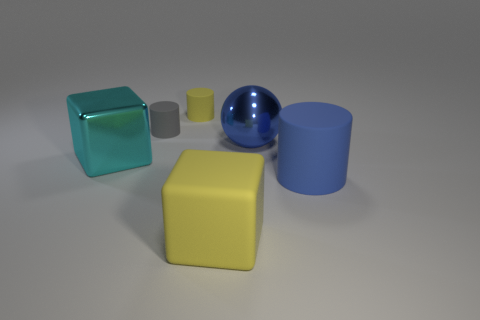There is a cylinder that is the same size as the ball; what color is it?
Give a very brief answer. Blue. What shape is the yellow rubber thing on the left side of the yellow thing in front of the large block that is on the left side of the small yellow matte cylinder?
Provide a succinct answer. Cylinder. There is a cylinder that is in front of the large cyan metallic block; how many blue cylinders are on the right side of it?
Offer a terse response. 0. Does the large metal object on the left side of the tiny gray rubber thing have the same shape as the yellow thing in front of the small gray cylinder?
Offer a very short reply. Yes. There is a large blue shiny sphere; what number of cyan cubes are in front of it?
Offer a very short reply. 1. Is the material of the large thing in front of the big blue matte thing the same as the big cyan thing?
Offer a very short reply. No. There is another matte thing that is the same shape as the large cyan thing; what is its color?
Make the answer very short. Yellow. The gray rubber thing is what shape?
Give a very brief answer. Cylinder. What number of objects are balls or big matte objects?
Ensure brevity in your answer.  3. Is the color of the cylinder right of the blue sphere the same as the large object that is behind the big metallic block?
Your response must be concise. Yes. 